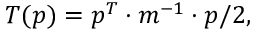<formula> <loc_0><loc_0><loc_500><loc_500>T ( p ) = p ^ { T } \cdot m ^ { - 1 } \cdot p / 2 ,</formula> 